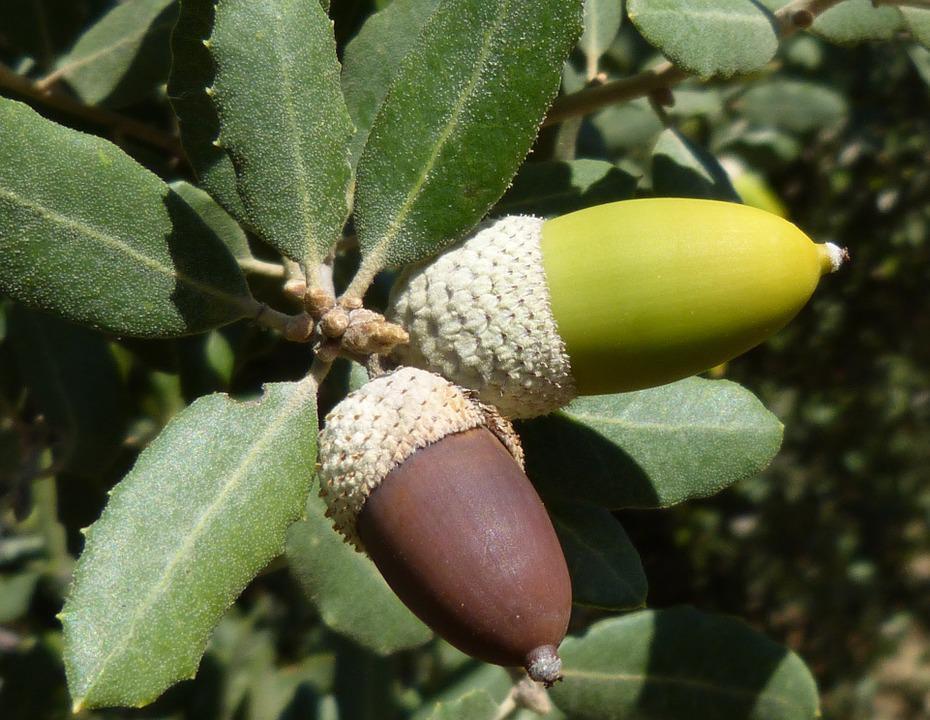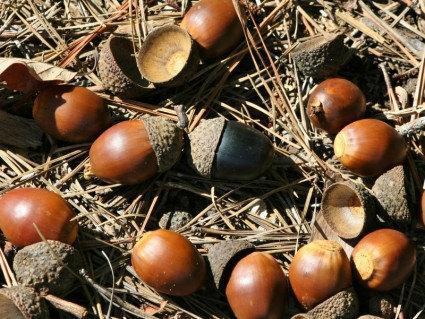The first image is the image on the left, the second image is the image on the right. Examine the images to the left and right. Is the description "Yellow citrus fruit grow in the tree in the image on the left." accurate? Answer yes or no. No. 